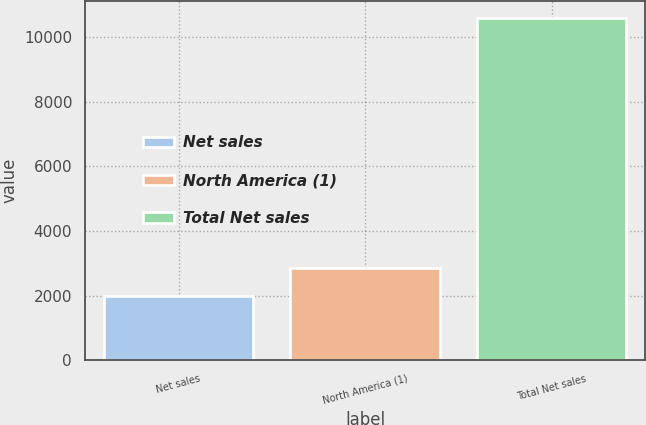<chart> <loc_0><loc_0><loc_500><loc_500><bar_chart><fcel>Net sales<fcel>North America (1)<fcel>Total Net sales<nl><fcel>2004<fcel>2862.02<fcel>10584.2<nl></chart> 